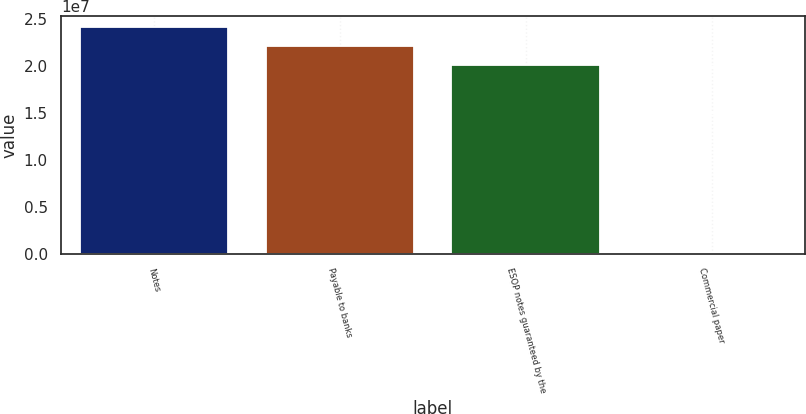<chart> <loc_0><loc_0><loc_500><loc_500><bar_chart><fcel>Notes<fcel>Payable to banks<fcel>ESOP notes guaranteed by the<fcel>Commercial paper<nl><fcel>2.4098e+07<fcel>2.209e+07<fcel>2.0082e+07<fcel>2008<nl></chart> 